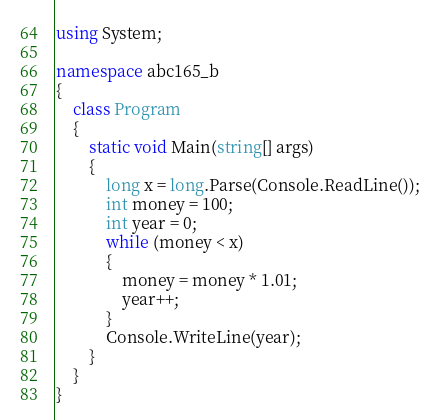Convert code to text. <code><loc_0><loc_0><loc_500><loc_500><_C#_>using System;

namespace abc165_b
{
    class Program
    {
        static void Main(string[] args)
        {
            long x = long.Parse(Console.ReadLine());
            int money = 100;
            int year = 0;
            while (money < x)
            {
                money = money * 1.01;
                year++;
            }
            Console.WriteLine(year);
        }
    }
}
</code> 